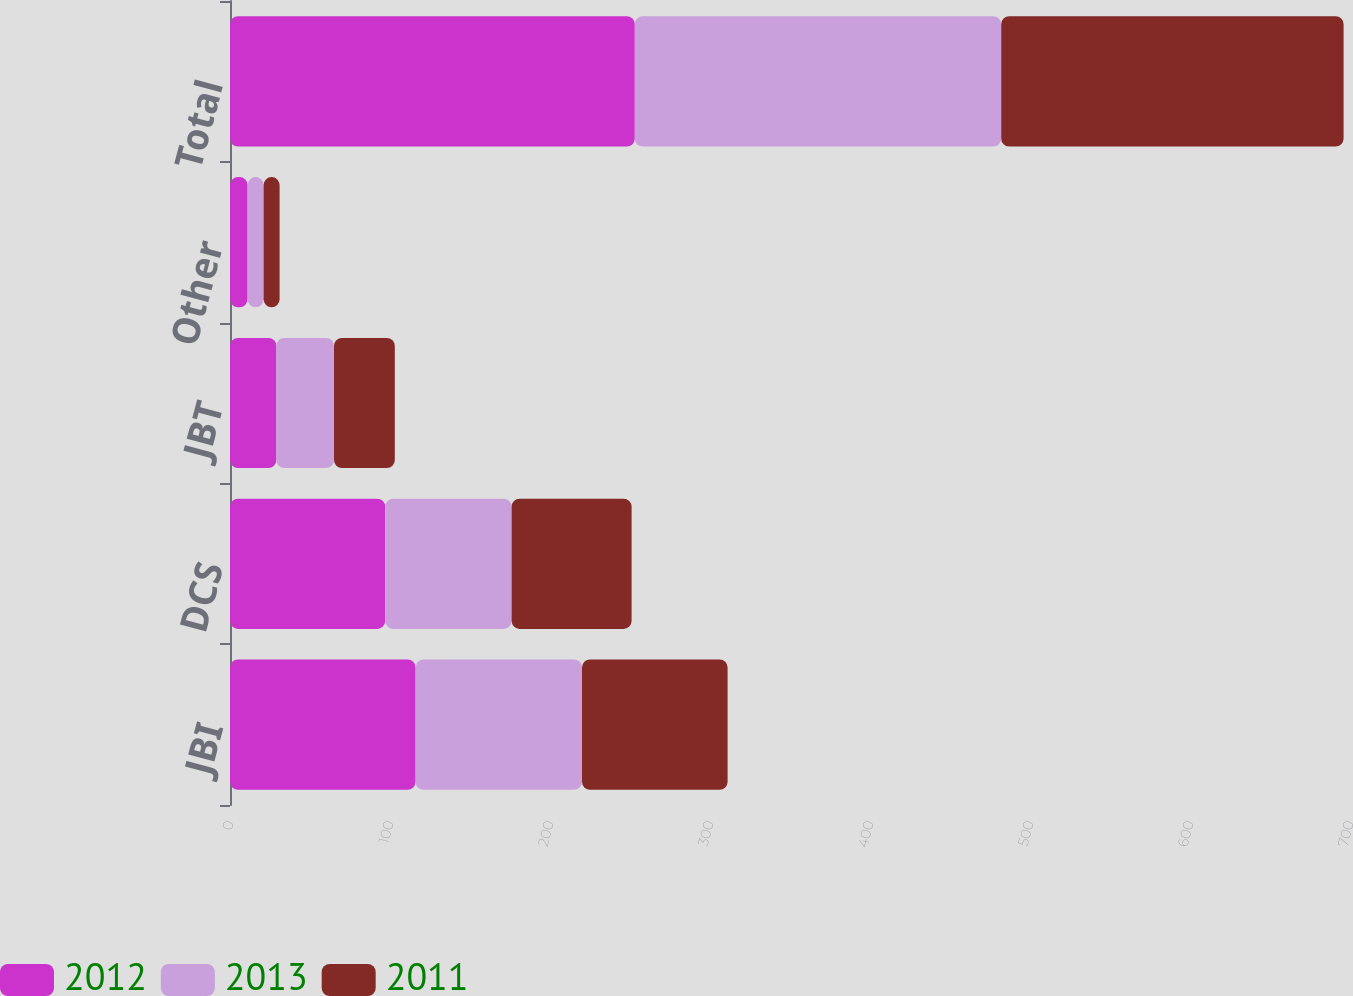<chart> <loc_0><loc_0><loc_500><loc_500><stacked_bar_chart><ecel><fcel>JBI<fcel>DCS<fcel>JBT<fcel>Other<fcel>Total<nl><fcel>2012<fcel>116<fcel>97<fcel>29<fcel>11<fcel>253<nl><fcel>2013<fcel>104<fcel>79<fcel>36<fcel>10<fcel>229<nl><fcel>2011<fcel>91<fcel>75<fcel>38<fcel>10<fcel>214<nl></chart> 